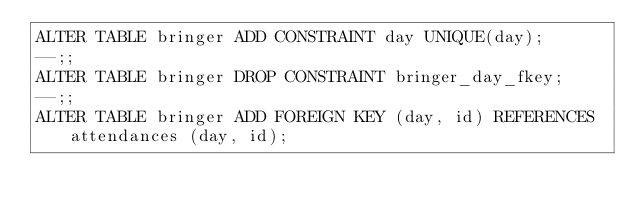<code> <loc_0><loc_0><loc_500><loc_500><_SQL_>ALTER TABLE bringer ADD CONSTRAINT day UNIQUE(day);
--;;
ALTER TABLE bringer DROP CONSTRAINT bringer_day_fkey;
--;;
ALTER TABLE bringer ADD FOREIGN KEY (day, id) REFERENCES attendances (day, id);
</code> 